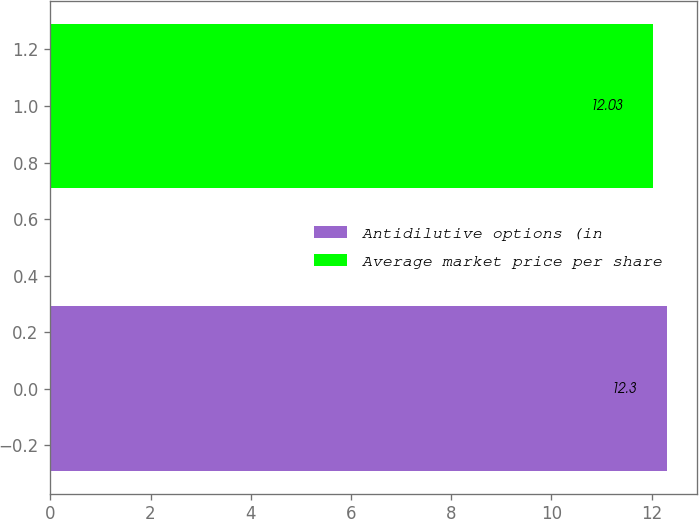Convert chart to OTSL. <chart><loc_0><loc_0><loc_500><loc_500><bar_chart><fcel>Antidilutive options (in<fcel>Average market price per share<nl><fcel>12.3<fcel>12.03<nl></chart> 